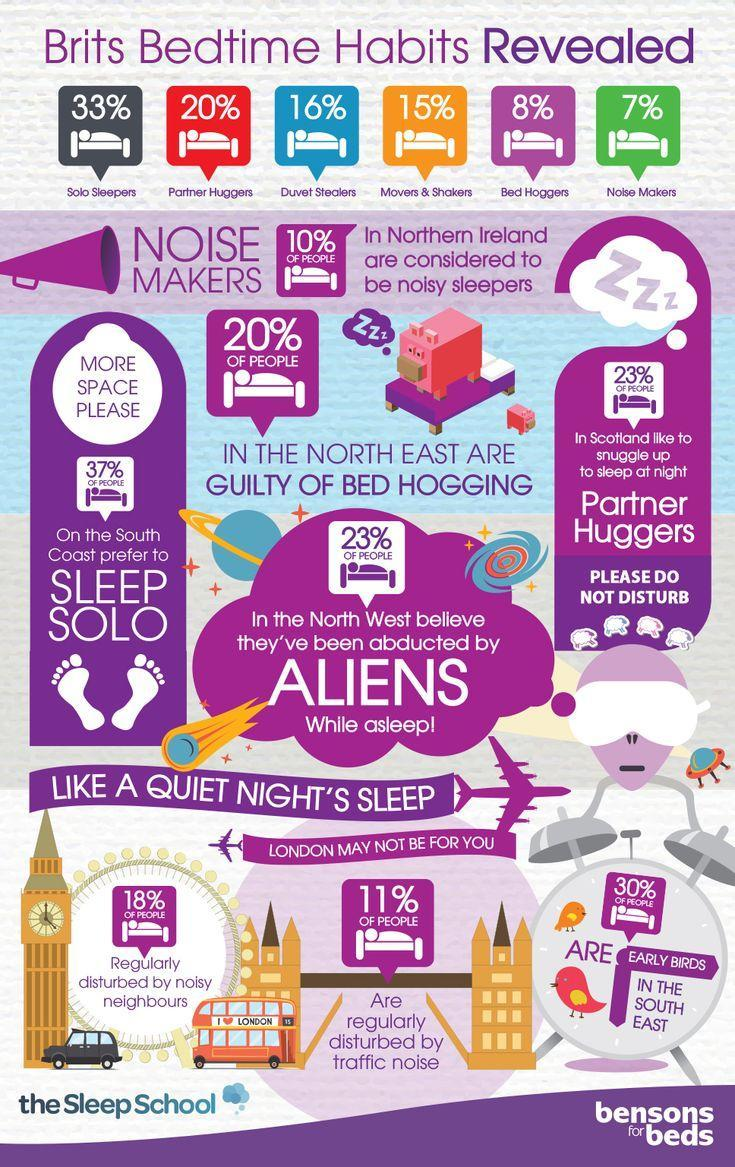What percentage of people in northern Ireland are considered to be noisy sleepers?
Answer the question with a short phrase. 10% What percentage of people in the south east of London are early birds? 30% What percentage of people in London are regularly disturbed by traffic noise? 11% What percentage of people in London are regularly disturbed by noisy neighbours? 18% What percentage of people in the north east are guilty of bed hogging? 20% What percentage of people on the south coast prefer to sleep solo? 37% What percentage of people in Scotland like to snuggle up to sleep at night? 23% 